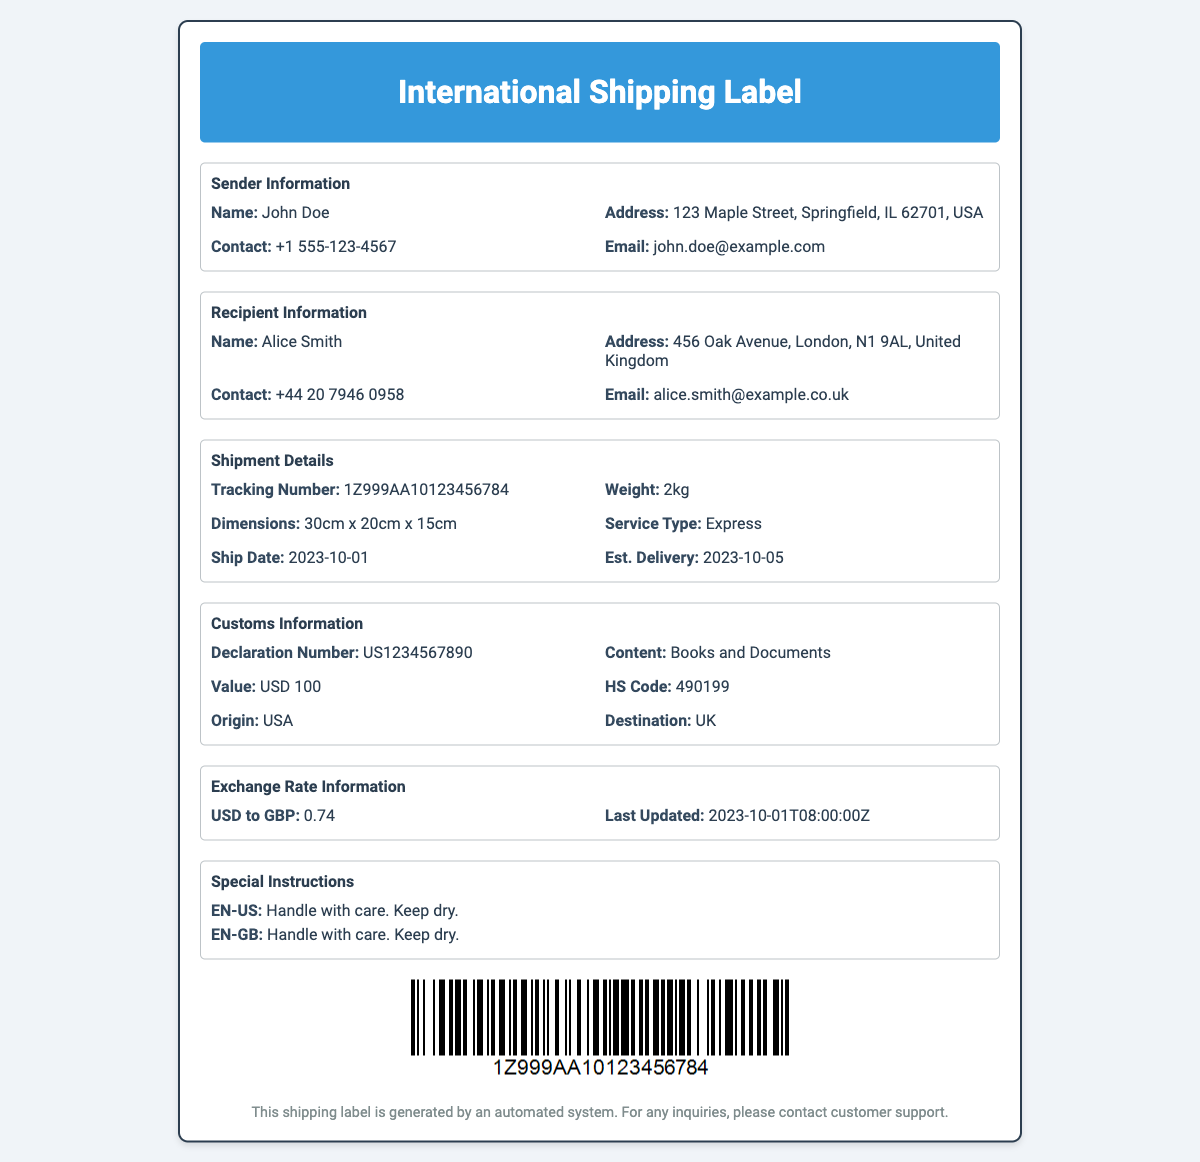what is the sender's name? The sender's name is listed in the sender information section of the document.
Answer: John Doe what is the recipient's address? The recipient's address is provided in the recipient information section.
Answer: 456 Oak Avenue, London, N1 9AL, United Kingdom what is the tracking number? The tracking number can be found under shipment details in the document.
Answer: 1Z999AA10123456784 when was the shipment date? The shipment date is mentioned in the shipment details section and reflects when the package was sent.
Answer: 2023-10-01 what is the declaration number? The declaration number is specified in the customs information section of the document.
Answer: US1234567890 what is the value of the shipment? The value of the shipment is listed in the customs information section and represents the worth of the items being shipped.
Answer: USD 100 what currency exchange rate is provided? The document contains specific exchange rate information pertinent to the currencies involved in the shipment.
Answer: 0.74 which services type is used for the shipment? The service type is noted in the shipment details section and indicates the delivery method chosen.
Answer: Express what special instruction is provided for handling? The special instructions section contains guidance on how the package should be treated during transit.
Answer: Handle with care. Keep dry 